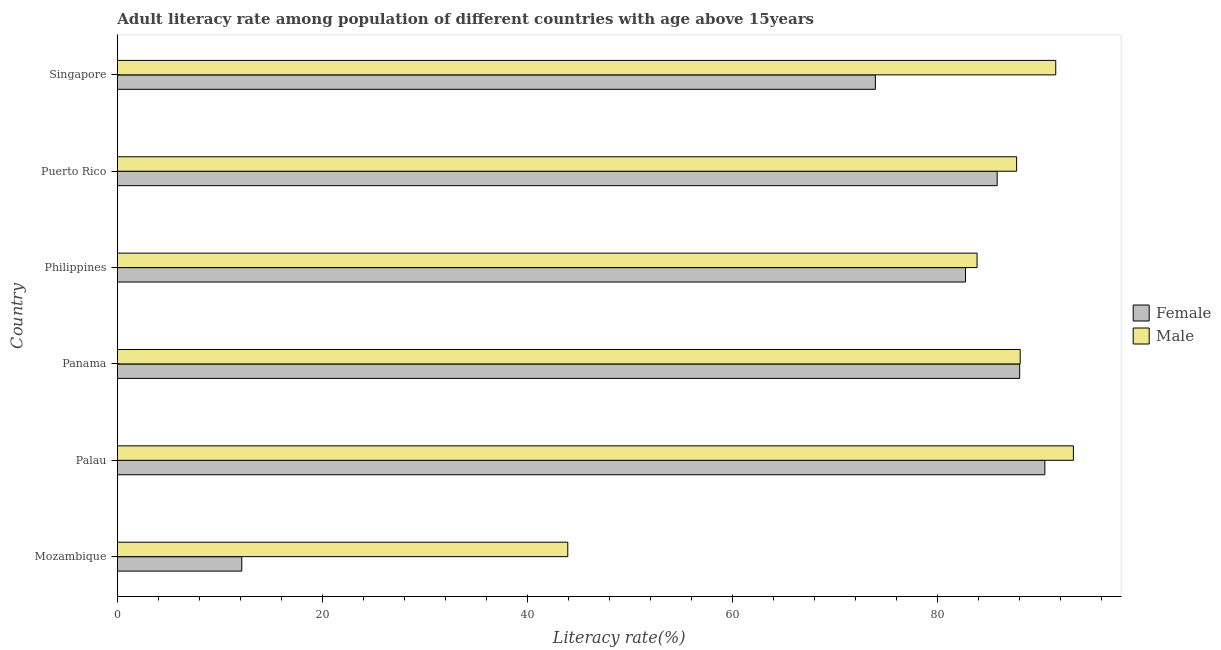How many different coloured bars are there?
Keep it short and to the point. 2. How many groups of bars are there?
Your response must be concise. 6. Are the number of bars per tick equal to the number of legend labels?
Provide a short and direct response. Yes. Are the number of bars on each tick of the Y-axis equal?
Provide a succinct answer. Yes. How many bars are there on the 4th tick from the top?
Ensure brevity in your answer.  2. What is the label of the 5th group of bars from the top?
Provide a succinct answer. Palau. What is the male adult literacy rate in Palau?
Ensure brevity in your answer.  93.29. Across all countries, what is the maximum female adult literacy rate?
Offer a very short reply. 90.5. Across all countries, what is the minimum male adult literacy rate?
Give a very brief answer. 43.95. In which country was the male adult literacy rate maximum?
Provide a short and direct response. Palau. In which country was the male adult literacy rate minimum?
Ensure brevity in your answer.  Mozambique. What is the total male adult literacy rate in the graph?
Your response must be concise. 488.54. What is the difference between the male adult literacy rate in Mozambique and that in Puerto Rico?
Provide a short and direct response. -43.79. What is the difference between the female adult literacy rate in Palau and the male adult literacy rate in Singapore?
Offer a terse response. -1.06. What is the average female adult literacy rate per country?
Ensure brevity in your answer.  72.21. What is the difference between the male adult literacy rate and female adult literacy rate in Puerto Rico?
Provide a short and direct response. 1.9. In how many countries, is the female adult literacy rate greater than 20 %?
Your answer should be very brief. 5. What is the ratio of the male adult literacy rate in Panama to that in Philippines?
Provide a succinct answer. 1.05. Is the male adult literacy rate in Mozambique less than that in Philippines?
Your response must be concise. Yes. Is the difference between the male adult literacy rate in Palau and Singapore greater than the difference between the female adult literacy rate in Palau and Singapore?
Offer a very short reply. No. What is the difference between the highest and the second highest female adult literacy rate?
Ensure brevity in your answer.  2.46. What is the difference between the highest and the lowest male adult literacy rate?
Your answer should be very brief. 49.33. Is the sum of the male adult literacy rate in Philippines and Puerto Rico greater than the maximum female adult literacy rate across all countries?
Your answer should be very brief. Yes. How many countries are there in the graph?
Provide a succinct answer. 6. Does the graph contain grids?
Ensure brevity in your answer.  No. Where does the legend appear in the graph?
Offer a very short reply. Center right. What is the title of the graph?
Provide a succinct answer. Adult literacy rate among population of different countries with age above 15years. Does "Electricity" appear as one of the legend labels in the graph?
Make the answer very short. No. What is the label or title of the X-axis?
Ensure brevity in your answer.  Literacy rate(%). What is the Literacy rate(%) of Female in Mozambique?
Your answer should be compact. 12.15. What is the Literacy rate(%) of Male in Mozambique?
Give a very brief answer. 43.95. What is the Literacy rate(%) in Female in Palau?
Your answer should be compact. 90.5. What is the Literacy rate(%) in Male in Palau?
Offer a terse response. 93.29. What is the Literacy rate(%) in Female in Panama?
Make the answer very short. 88.05. What is the Literacy rate(%) in Male in Panama?
Provide a succinct answer. 88.1. What is the Literacy rate(%) in Female in Philippines?
Your answer should be very brief. 82.76. What is the Literacy rate(%) of Male in Philippines?
Your answer should be compact. 83.89. What is the Literacy rate(%) of Female in Puerto Rico?
Keep it short and to the point. 85.85. What is the Literacy rate(%) of Male in Puerto Rico?
Your response must be concise. 87.75. What is the Literacy rate(%) of Female in Singapore?
Your answer should be compact. 73.97. What is the Literacy rate(%) of Male in Singapore?
Your answer should be very brief. 91.57. Across all countries, what is the maximum Literacy rate(%) in Female?
Ensure brevity in your answer.  90.5. Across all countries, what is the maximum Literacy rate(%) in Male?
Ensure brevity in your answer.  93.29. Across all countries, what is the minimum Literacy rate(%) in Female?
Your answer should be very brief. 12.15. Across all countries, what is the minimum Literacy rate(%) in Male?
Make the answer very short. 43.95. What is the total Literacy rate(%) of Female in the graph?
Give a very brief answer. 433.28. What is the total Literacy rate(%) of Male in the graph?
Provide a short and direct response. 488.54. What is the difference between the Literacy rate(%) of Female in Mozambique and that in Palau?
Provide a succinct answer. -78.36. What is the difference between the Literacy rate(%) in Male in Mozambique and that in Palau?
Ensure brevity in your answer.  -49.33. What is the difference between the Literacy rate(%) in Female in Mozambique and that in Panama?
Your response must be concise. -75.9. What is the difference between the Literacy rate(%) in Male in Mozambique and that in Panama?
Offer a very short reply. -44.14. What is the difference between the Literacy rate(%) of Female in Mozambique and that in Philippines?
Your response must be concise. -70.62. What is the difference between the Literacy rate(%) in Male in Mozambique and that in Philippines?
Your answer should be compact. -39.93. What is the difference between the Literacy rate(%) of Female in Mozambique and that in Puerto Rico?
Give a very brief answer. -73.7. What is the difference between the Literacy rate(%) in Male in Mozambique and that in Puerto Rico?
Provide a short and direct response. -43.79. What is the difference between the Literacy rate(%) in Female in Mozambique and that in Singapore?
Provide a succinct answer. -61.82. What is the difference between the Literacy rate(%) in Male in Mozambique and that in Singapore?
Offer a terse response. -47.61. What is the difference between the Literacy rate(%) of Female in Palau and that in Panama?
Ensure brevity in your answer.  2.46. What is the difference between the Literacy rate(%) of Male in Palau and that in Panama?
Keep it short and to the point. 5.19. What is the difference between the Literacy rate(%) of Female in Palau and that in Philippines?
Provide a short and direct response. 7.74. What is the difference between the Literacy rate(%) of Male in Palau and that in Philippines?
Your answer should be compact. 9.4. What is the difference between the Literacy rate(%) of Female in Palau and that in Puerto Rico?
Offer a terse response. 4.65. What is the difference between the Literacy rate(%) of Male in Palau and that in Puerto Rico?
Your answer should be compact. 5.54. What is the difference between the Literacy rate(%) of Female in Palau and that in Singapore?
Your response must be concise. 16.53. What is the difference between the Literacy rate(%) of Male in Palau and that in Singapore?
Ensure brevity in your answer.  1.72. What is the difference between the Literacy rate(%) of Female in Panama and that in Philippines?
Ensure brevity in your answer.  5.28. What is the difference between the Literacy rate(%) in Male in Panama and that in Philippines?
Provide a succinct answer. 4.21. What is the difference between the Literacy rate(%) of Female in Panama and that in Puerto Rico?
Make the answer very short. 2.2. What is the difference between the Literacy rate(%) in Male in Panama and that in Puerto Rico?
Offer a very short reply. 0.35. What is the difference between the Literacy rate(%) in Female in Panama and that in Singapore?
Provide a succinct answer. 14.08. What is the difference between the Literacy rate(%) in Male in Panama and that in Singapore?
Provide a short and direct response. -3.47. What is the difference between the Literacy rate(%) of Female in Philippines and that in Puerto Rico?
Your answer should be compact. -3.09. What is the difference between the Literacy rate(%) of Male in Philippines and that in Puerto Rico?
Give a very brief answer. -3.86. What is the difference between the Literacy rate(%) of Female in Philippines and that in Singapore?
Give a very brief answer. 8.79. What is the difference between the Literacy rate(%) of Male in Philippines and that in Singapore?
Keep it short and to the point. -7.68. What is the difference between the Literacy rate(%) in Female in Puerto Rico and that in Singapore?
Make the answer very short. 11.88. What is the difference between the Literacy rate(%) of Male in Puerto Rico and that in Singapore?
Keep it short and to the point. -3.82. What is the difference between the Literacy rate(%) in Female in Mozambique and the Literacy rate(%) in Male in Palau?
Your answer should be compact. -81.14. What is the difference between the Literacy rate(%) of Female in Mozambique and the Literacy rate(%) of Male in Panama?
Provide a succinct answer. -75.95. What is the difference between the Literacy rate(%) of Female in Mozambique and the Literacy rate(%) of Male in Philippines?
Provide a short and direct response. -71.74. What is the difference between the Literacy rate(%) of Female in Mozambique and the Literacy rate(%) of Male in Puerto Rico?
Your answer should be compact. -75.6. What is the difference between the Literacy rate(%) in Female in Mozambique and the Literacy rate(%) in Male in Singapore?
Offer a terse response. -79.42. What is the difference between the Literacy rate(%) in Female in Palau and the Literacy rate(%) in Male in Panama?
Provide a succinct answer. 2.41. What is the difference between the Literacy rate(%) in Female in Palau and the Literacy rate(%) in Male in Philippines?
Provide a short and direct response. 6.61. What is the difference between the Literacy rate(%) of Female in Palau and the Literacy rate(%) of Male in Puerto Rico?
Offer a very short reply. 2.76. What is the difference between the Literacy rate(%) of Female in Palau and the Literacy rate(%) of Male in Singapore?
Offer a terse response. -1.06. What is the difference between the Literacy rate(%) of Female in Panama and the Literacy rate(%) of Male in Philippines?
Give a very brief answer. 4.16. What is the difference between the Literacy rate(%) of Female in Panama and the Literacy rate(%) of Male in Puerto Rico?
Your response must be concise. 0.3. What is the difference between the Literacy rate(%) in Female in Panama and the Literacy rate(%) in Male in Singapore?
Your answer should be compact. -3.52. What is the difference between the Literacy rate(%) of Female in Philippines and the Literacy rate(%) of Male in Puerto Rico?
Ensure brevity in your answer.  -4.99. What is the difference between the Literacy rate(%) in Female in Philippines and the Literacy rate(%) in Male in Singapore?
Your answer should be very brief. -8.8. What is the difference between the Literacy rate(%) in Female in Puerto Rico and the Literacy rate(%) in Male in Singapore?
Your answer should be compact. -5.72. What is the average Literacy rate(%) in Female per country?
Your answer should be compact. 72.21. What is the average Literacy rate(%) in Male per country?
Offer a very short reply. 81.42. What is the difference between the Literacy rate(%) in Female and Literacy rate(%) in Male in Mozambique?
Offer a very short reply. -31.81. What is the difference between the Literacy rate(%) of Female and Literacy rate(%) of Male in Palau?
Make the answer very short. -2.78. What is the difference between the Literacy rate(%) of Female and Literacy rate(%) of Male in Panama?
Provide a short and direct response. -0.05. What is the difference between the Literacy rate(%) of Female and Literacy rate(%) of Male in Philippines?
Provide a succinct answer. -1.13. What is the difference between the Literacy rate(%) in Female and Literacy rate(%) in Male in Puerto Rico?
Provide a short and direct response. -1.9. What is the difference between the Literacy rate(%) of Female and Literacy rate(%) of Male in Singapore?
Your response must be concise. -17.6. What is the ratio of the Literacy rate(%) of Female in Mozambique to that in Palau?
Offer a very short reply. 0.13. What is the ratio of the Literacy rate(%) of Male in Mozambique to that in Palau?
Offer a very short reply. 0.47. What is the ratio of the Literacy rate(%) of Female in Mozambique to that in Panama?
Give a very brief answer. 0.14. What is the ratio of the Literacy rate(%) of Male in Mozambique to that in Panama?
Give a very brief answer. 0.5. What is the ratio of the Literacy rate(%) in Female in Mozambique to that in Philippines?
Offer a terse response. 0.15. What is the ratio of the Literacy rate(%) of Male in Mozambique to that in Philippines?
Ensure brevity in your answer.  0.52. What is the ratio of the Literacy rate(%) of Female in Mozambique to that in Puerto Rico?
Offer a very short reply. 0.14. What is the ratio of the Literacy rate(%) in Male in Mozambique to that in Puerto Rico?
Your answer should be compact. 0.5. What is the ratio of the Literacy rate(%) of Female in Mozambique to that in Singapore?
Give a very brief answer. 0.16. What is the ratio of the Literacy rate(%) in Male in Mozambique to that in Singapore?
Ensure brevity in your answer.  0.48. What is the ratio of the Literacy rate(%) of Female in Palau to that in Panama?
Offer a terse response. 1.03. What is the ratio of the Literacy rate(%) of Male in Palau to that in Panama?
Ensure brevity in your answer.  1.06. What is the ratio of the Literacy rate(%) in Female in Palau to that in Philippines?
Keep it short and to the point. 1.09. What is the ratio of the Literacy rate(%) in Male in Palau to that in Philippines?
Your answer should be compact. 1.11. What is the ratio of the Literacy rate(%) of Female in Palau to that in Puerto Rico?
Make the answer very short. 1.05. What is the ratio of the Literacy rate(%) in Male in Palau to that in Puerto Rico?
Offer a very short reply. 1.06. What is the ratio of the Literacy rate(%) of Female in Palau to that in Singapore?
Provide a succinct answer. 1.22. What is the ratio of the Literacy rate(%) of Male in Palau to that in Singapore?
Provide a short and direct response. 1.02. What is the ratio of the Literacy rate(%) in Female in Panama to that in Philippines?
Offer a terse response. 1.06. What is the ratio of the Literacy rate(%) of Male in Panama to that in Philippines?
Provide a succinct answer. 1.05. What is the ratio of the Literacy rate(%) of Female in Panama to that in Puerto Rico?
Offer a very short reply. 1.03. What is the ratio of the Literacy rate(%) in Female in Panama to that in Singapore?
Your response must be concise. 1.19. What is the ratio of the Literacy rate(%) in Male in Panama to that in Singapore?
Provide a succinct answer. 0.96. What is the ratio of the Literacy rate(%) of Male in Philippines to that in Puerto Rico?
Your answer should be very brief. 0.96. What is the ratio of the Literacy rate(%) of Female in Philippines to that in Singapore?
Provide a succinct answer. 1.12. What is the ratio of the Literacy rate(%) in Male in Philippines to that in Singapore?
Your answer should be compact. 0.92. What is the ratio of the Literacy rate(%) in Female in Puerto Rico to that in Singapore?
Keep it short and to the point. 1.16. What is the difference between the highest and the second highest Literacy rate(%) of Female?
Your answer should be compact. 2.46. What is the difference between the highest and the second highest Literacy rate(%) in Male?
Your response must be concise. 1.72. What is the difference between the highest and the lowest Literacy rate(%) in Female?
Offer a very short reply. 78.36. What is the difference between the highest and the lowest Literacy rate(%) in Male?
Offer a very short reply. 49.33. 